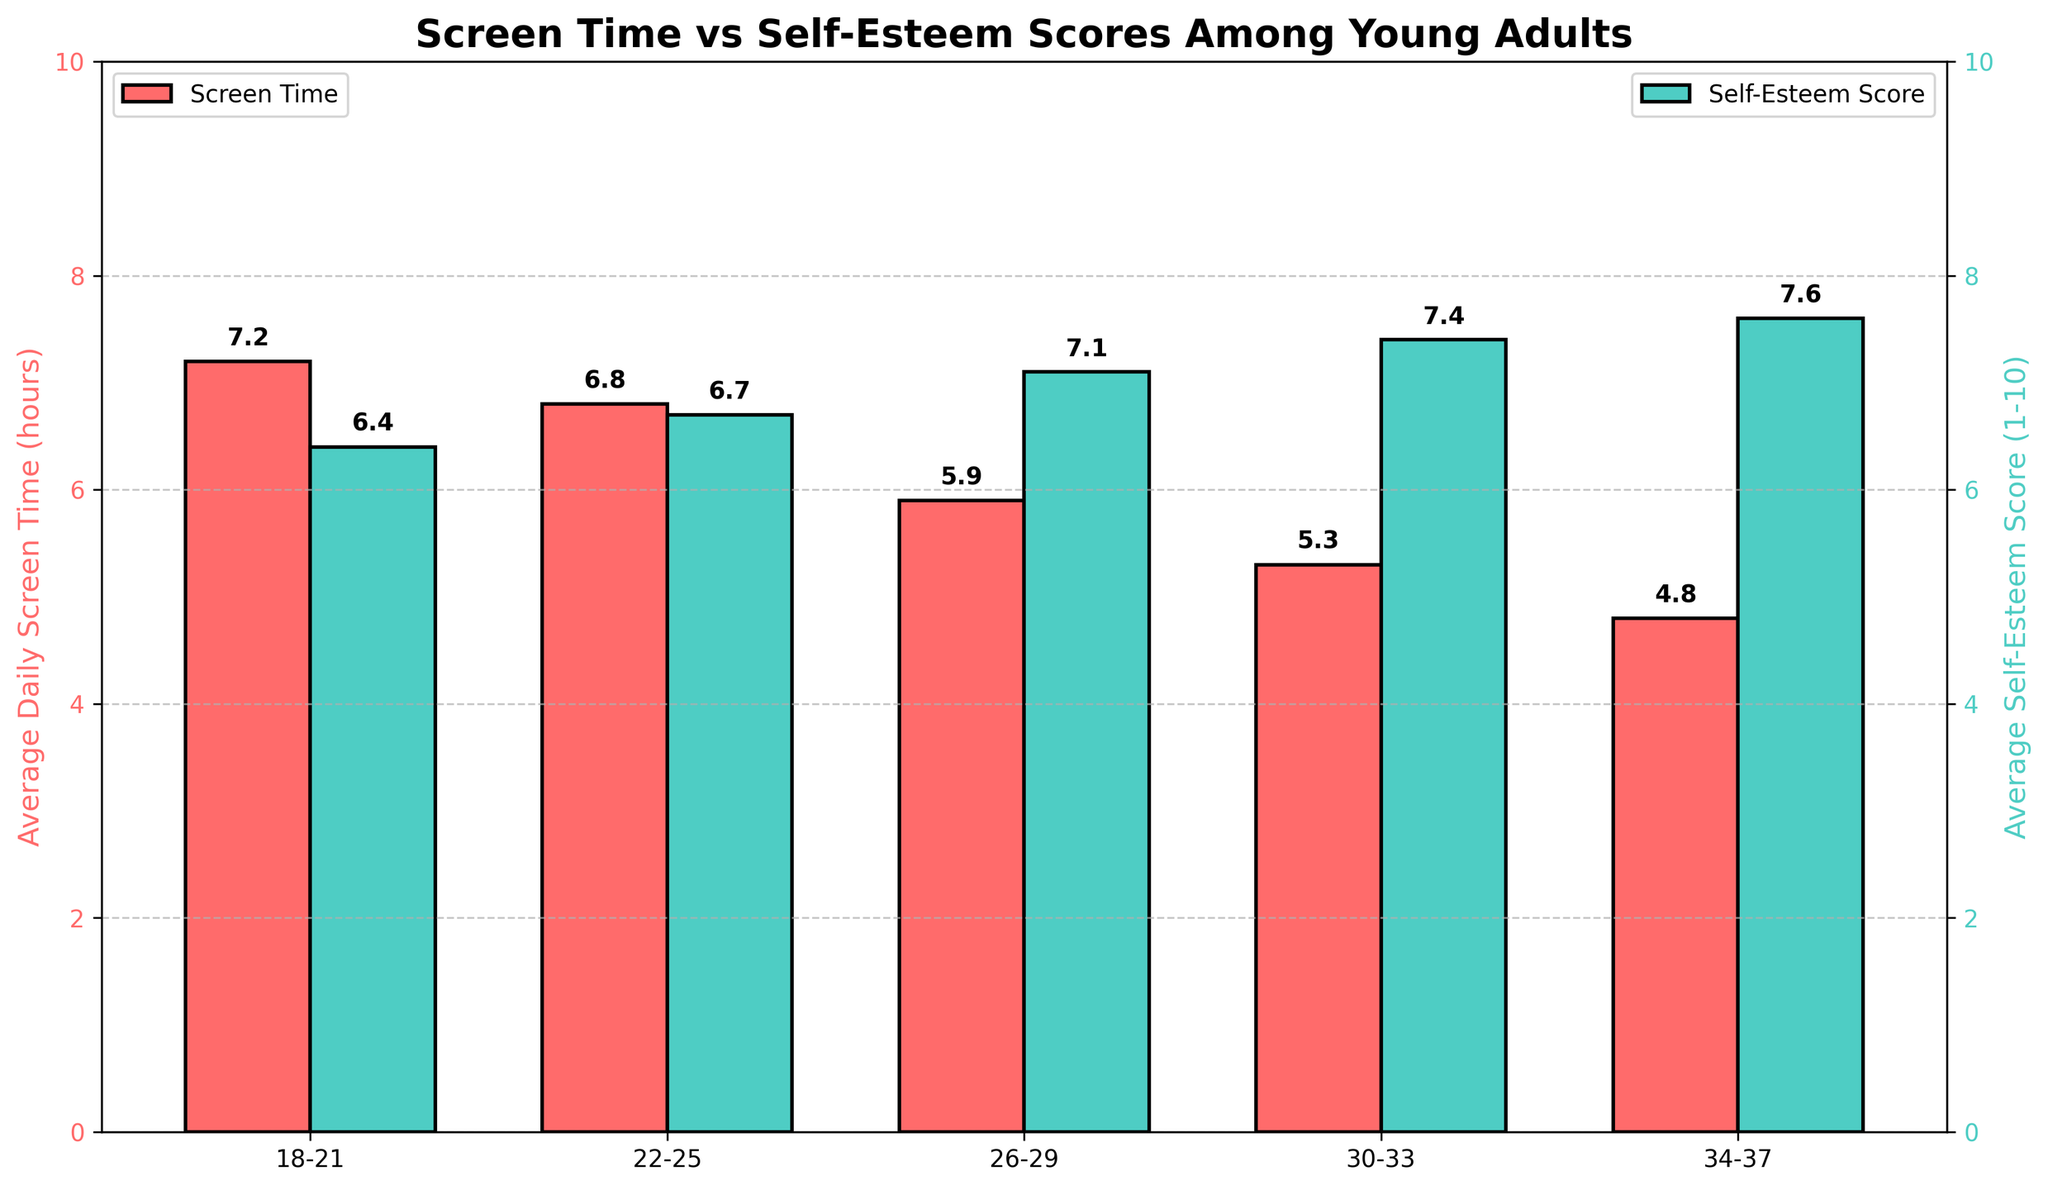Which age group has the highest average daily screen time? By looking at the height of the red bars in the figure, we can see that the age group '18-21' has the highest average daily screen time of 7.2 hours.
Answer: 18-21 Which age group has the highest average self-esteem score? By looking at the height of the green bars in the figure, we see that the age group '34-37' has the highest average self-esteem score of 7.6.
Answer: 34-37 What is the difference in average daily screen time between the age groups '18-21' and '34-37'? The average daily screen time for '18-21' is 7.2 hours and for '34-37' it is 4.8 hours. Subtracting 4.8 from 7.2 gives us the difference, 7.2 - 4.8 = 2.4.
Answer: 2.4 What is the total average daily screen time for all the age groups combined? Add up the average daily screen time for each age group: 7.2 + 6.8 + 5.9 + 5.3 + 4.8 = 30.
Answer: 30 Which age group has the lowest average self-esteem score? By observing the height of the green bars, we see the '18-21' age group has the lowest average self-esteem score of 6.4.
Answer: 18-21 Is there an inverse relationship between average daily screen time and average self-esteem score across the age groups? Yes, as the average daily screen time decreases from younger to older age groups, the average self-esteem score increases, indicating an inverse relationship.
Answer: Yes What is the average of the self-esteem scores for the age groups '26-29' and '30-33'? The self-esteem scores for '26-29' and '30-33' are 7.1 and 7.4, respectively. The average is (7.1 + 7.4) / 2 = 7.25.
Answer: 7.25 How does the self-esteem score for the '30-33' age group compare to its screen time? The green bar representing self-esteem score for '30-33' is higher than the red bar representing screen time, indicating higher self-esteem (7.4) and lower screen time (5.3).
Answer: Higher Between which age groups is the average daily screen time drop the largest? By examining the red bars, the largest drop in screen time is between '22-25' (6.8) and '26-29' (5.9). The drop is 6.8 - 5.9 = 0.9 hours.
Answer: 22-25 and 26-29 What is the range of the average self-esteem scores across the age groups? The lowest average self-esteem score is 6.4 (age group 18-21), and the highest is 7.6 (age group 34-37). The range is 7.6 - 6.4 = 1.2.
Answer: 1.2 